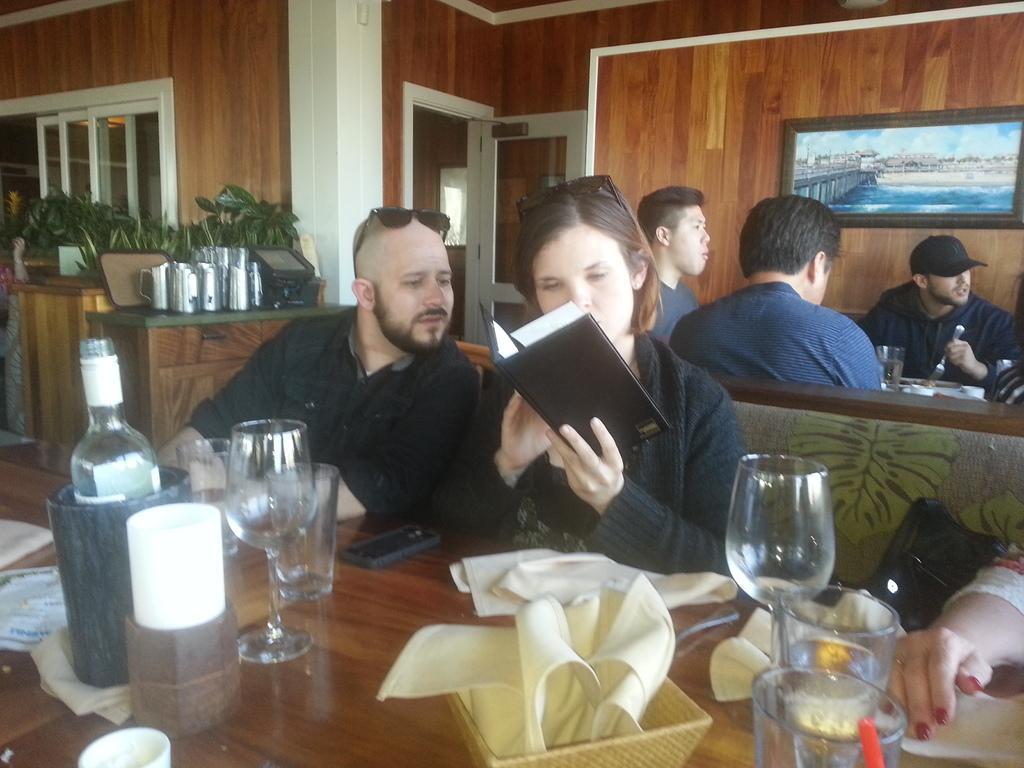Could you give a brief overview of what you see in this image? There is a group of people. The persons are sitting like a restaurant. The two persons are sat on front chairs and other 3 persons are backside of the chairs. The front row person is holding like menu book. They have a table in front of them above the tables is glass,water bottle,and tissues. There is a flower competition next to the window. The man was next to the window. On the background we can see doors and photo frames. 